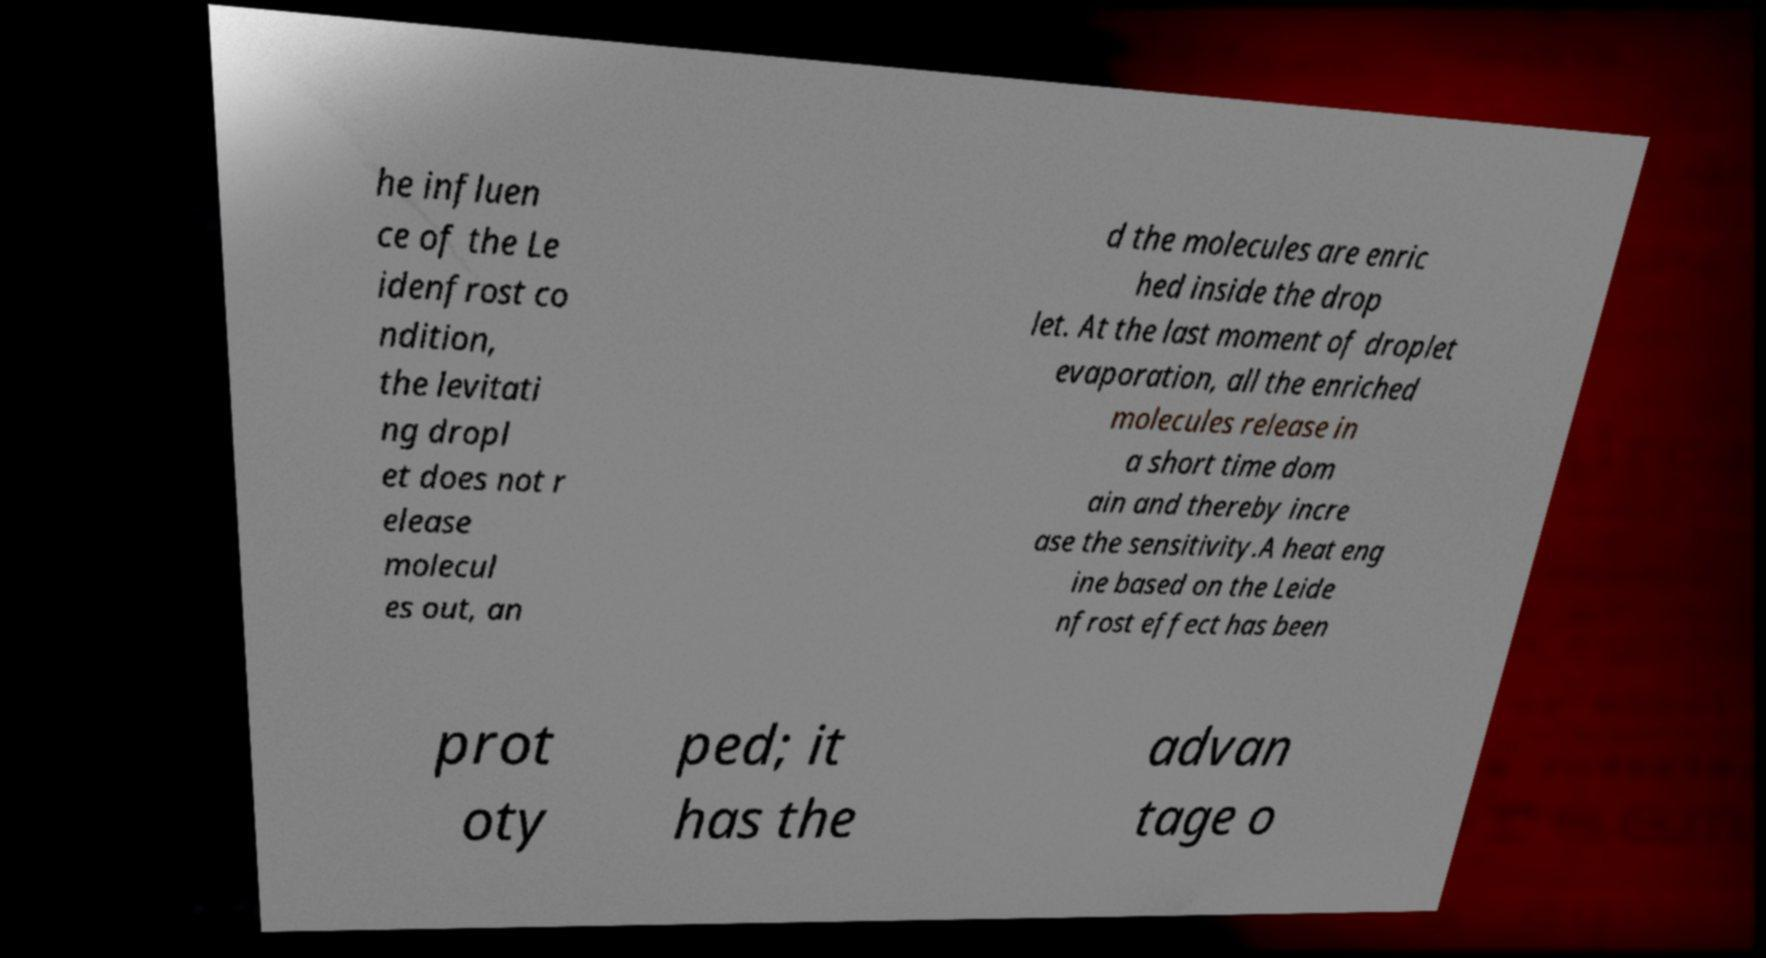Could you assist in decoding the text presented in this image and type it out clearly? he influen ce of the Le idenfrost co ndition, the levitati ng dropl et does not r elease molecul es out, an d the molecules are enric hed inside the drop let. At the last moment of droplet evaporation, all the enriched molecules release in a short time dom ain and thereby incre ase the sensitivity.A heat eng ine based on the Leide nfrost effect has been prot oty ped; it has the advan tage o 